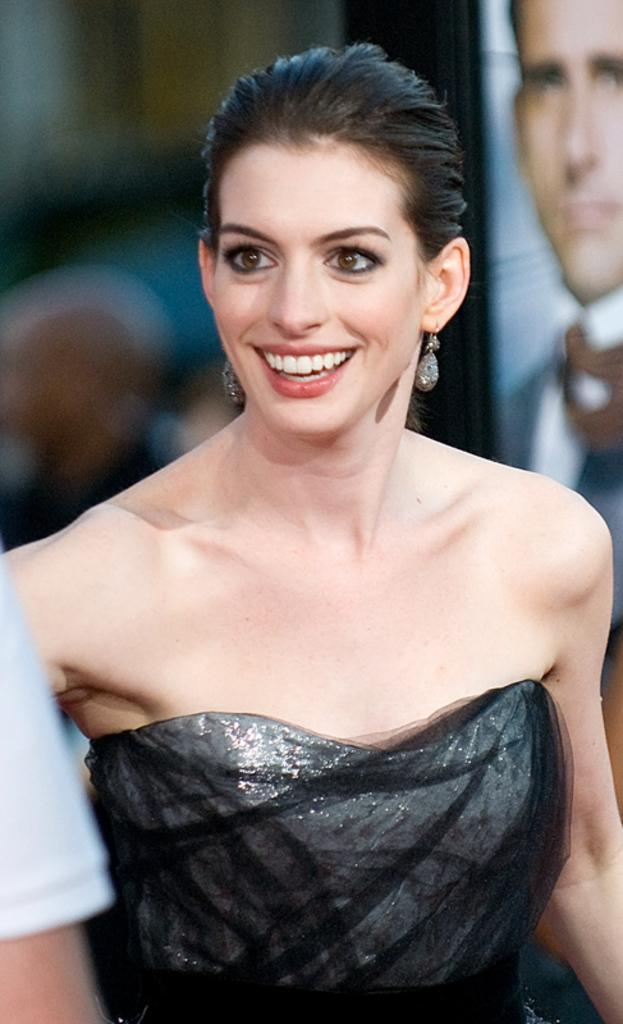Who is the main subject in the image? There is a lady in the center of the image. What is the lady doing in the image? The lady is standing and smiling. What is the lady wearing in the image? The lady is wearing a black dress. What can be seen on the right side of the image? There is a board on the right side of the image. What type of shoe is the lady wearing in the image? The provided facts do not mention any shoes, so we cannot determine the type of shoe the lady is wearing in the image. 